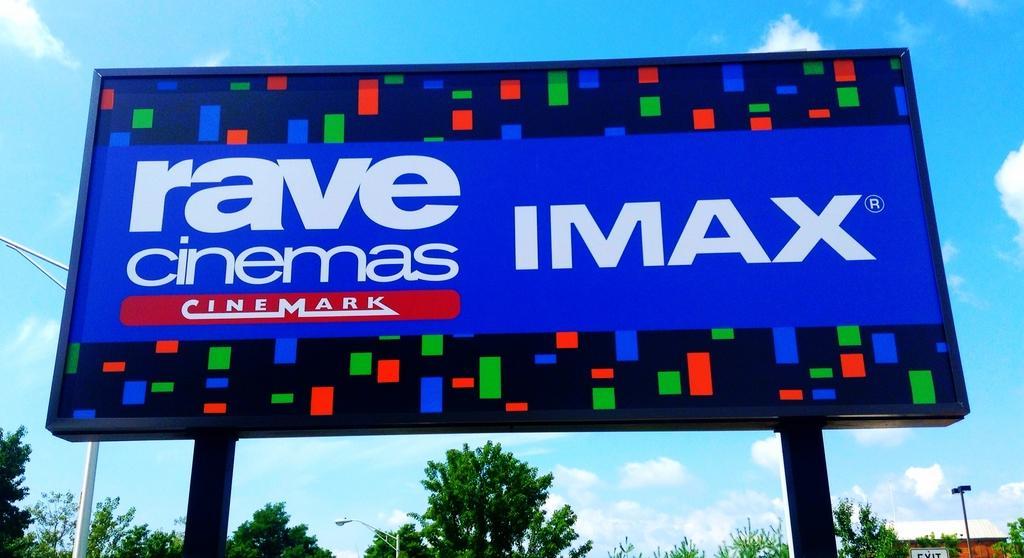Please provide a concise description of this image. In the picture I can see a blue color hoarding on which I can see some text. In the background, I can see light poles, trees, house and the blue color sky with clouds. 